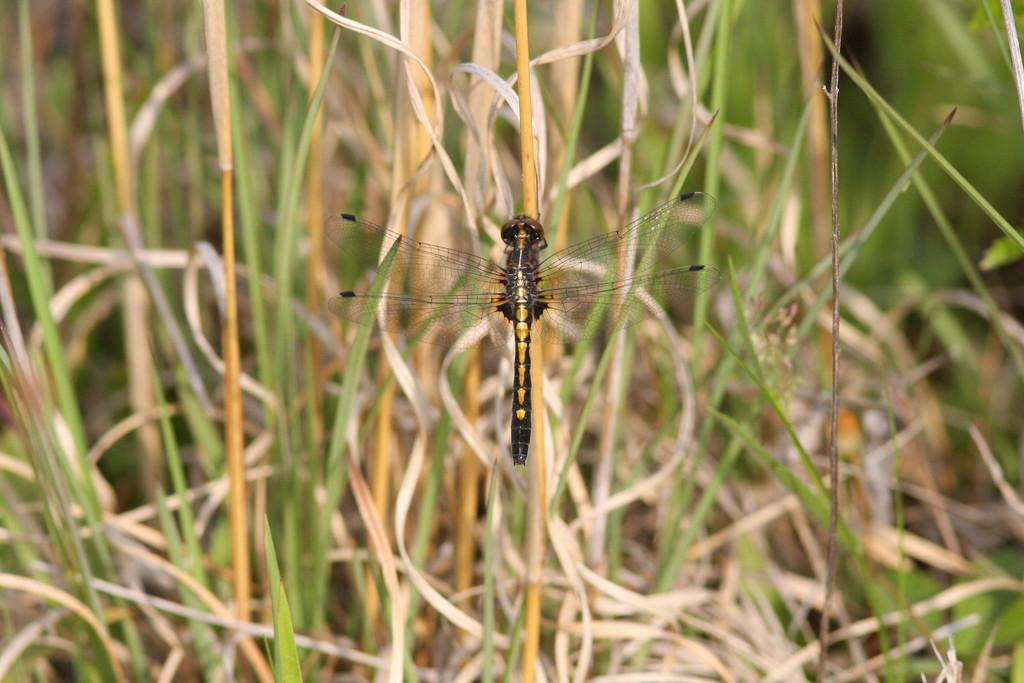How would you summarize this image in a sentence or two? In the center of the image, we can see a dragonfly and in the background, there is grass. 